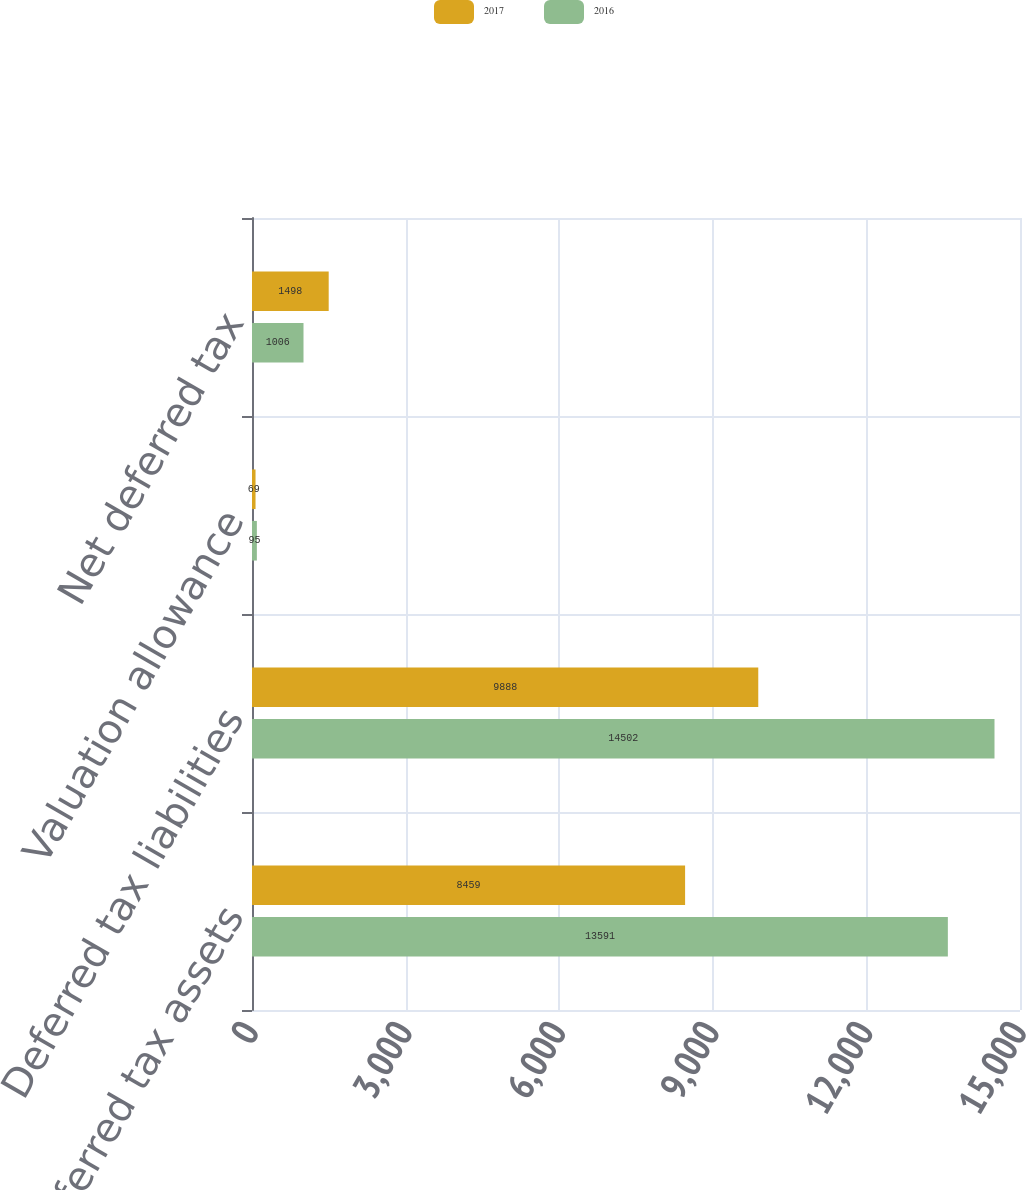Convert chart to OTSL. <chart><loc_0><loc_0><loc_500><loc_500><stacked_bar_chart><ecel><fcel>Deferred tax assets<fcel>Deferred tax liabilities<fcel>Valuation allowance<fcel>Net deferred tax<nl><fcel>2017<fcel>8459<fcel>9888<fcel>69<fcel>1498<nl><fcel>2016<fcel>13591<fcel>14502<fcel>95<fcel>1006<nl></chart> 